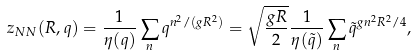Convert formula to latex. <formula><loc_0><loc_0><loc_500><loc_500>z _ { N N } ( R , q ) = \frac { 1 } { \eta { ( q ) } } \sum _ { n } q ^ { n ^ { 2 } / ( g R ^ { 2 } ) } = \sqrt { \frac { g R } { 2 } } \frac { 1 } { \eta { ( \tilde { q } ) } } \sum _ { n } \tilde { q } ^ { g n ^ { 2 } R ^ { 2 } / 4 } ,</formula> 